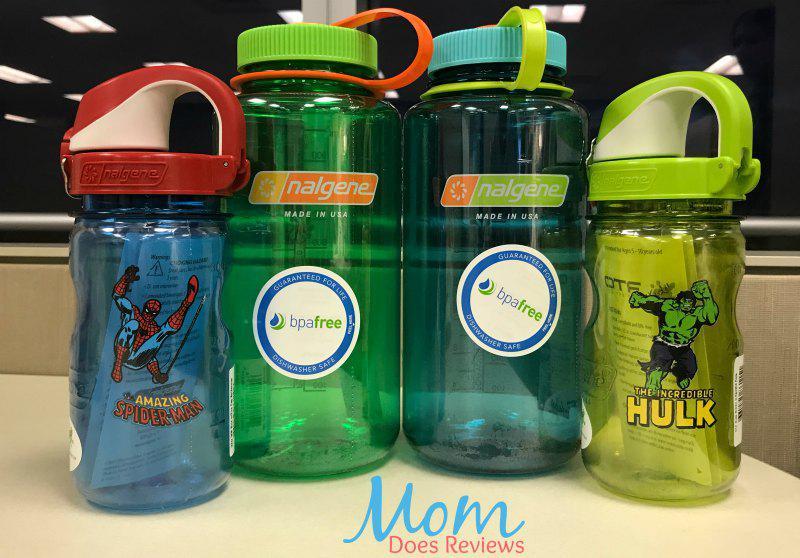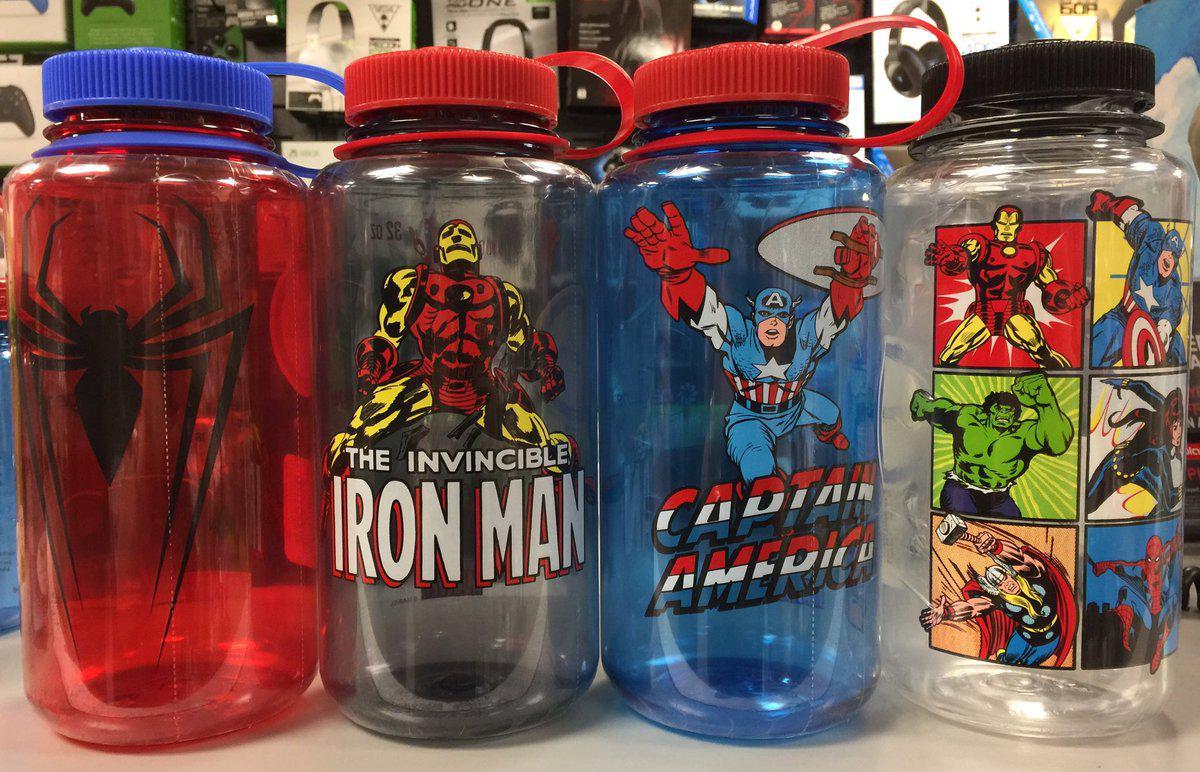The first image is the image on the left, the second image is the image on the right. Considering the images on both sides, is "The left and right image contains the same number of plastic bottles." valid? Answer yes or no. Yes. The first image is the image on the left, the second image is the image on the right. Evaluate the accuracy of this statement regarding the images: "One image contains a single water bottle, and the other image contains at least seven water bottles.". Is it true? Answer yes or no. No. 